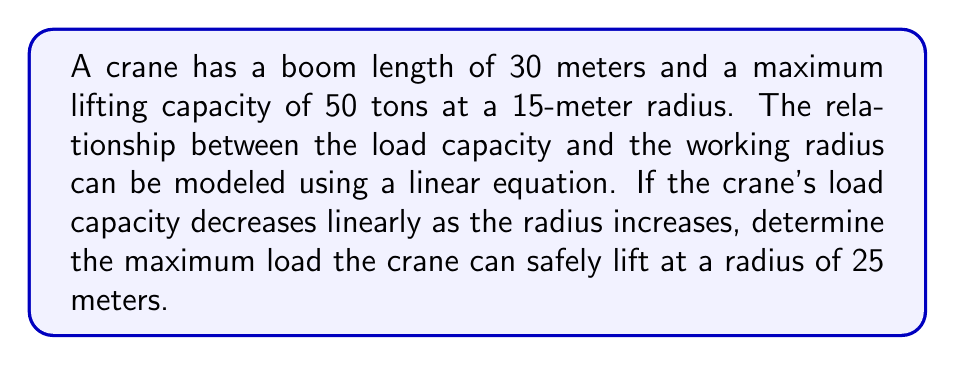Show me your answer to this math problem. To solve this problem, we'll use a linear equation to model the relationship between the load capacity and the working radius. Let's follow these steps:

1. Define variables:
   $x$ = working radius (in meters)
   $y$ = load capacity (in tons)

2. We know two points on this line:
   $(15, 50)$ : At a 15-meter radius, the capacity is 50 tons
   $(30, 0)$ : At the maximum boom length of 30 meters, we assume the capacity is 0 tons

3. Use the point-slope form of a line to create our equation:
   $y - y_1 = m(x - x_1)$
   
   Where $m$ is the slope, calculated as:
   $$m = \frac{y_2 - y_1}{x_2 - x_1} = \frac{0 - 50}{30 - 15} = -\frac{10}{3}$$

4. Substitute the known values into the point-slope form:
   $y - 50 = -\frac{10}{3}(x - 15)$

5. Simplify to get the slope-intercept form:
   $y = -\frac{10}{3}x + 100$

6. Now we can calculate the load capacity at a 25-meter radius by substituting $x = 25$:
   $$y = -\frac{10}{3}(25) + 100$$
   $$y = -83.33 + 100 = 16.67$$

Therefore, the maximum load the crane can safely lift at a 25-meter radius is approximately 16.67 tons.
Answer: 16.67 tons 